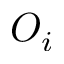Convert formula to latex. <formula><loc_0><loc_0><loc_500><loc_500>O _ { i }</formula> 